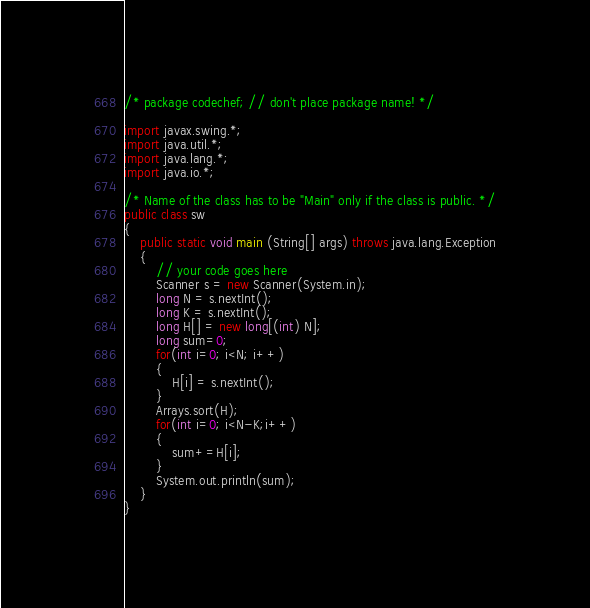<code> <loc_0><loc_0><loc_500><loc_500><_Java_>/* package codechef; // don't place package name! */

import javax.swing.*;
import java.util.*;
import java.lang.*;
import java.io.*;

/* Name of the class has to be "Main" only if the class is public. */
public class sw
{
    public static void main (String[] args) throws java.lang.Exception
    {
        // your code goes here
        Scanner s = new Scanner(System.in);
        long N = s.nextInt();
        long K = s.nextInt();
        long H[] = new long[(int) N];
        long sum=0;
        for(int i=0; i<N; i++)
        {
            H[i] = s.nextInt();
        }
        Arrays.sort(H);
        for(int i=0; i<N-K;i++)
        {
            sum+=H[i];
        }
        System.out.println(sum);
    }
}
</code> 